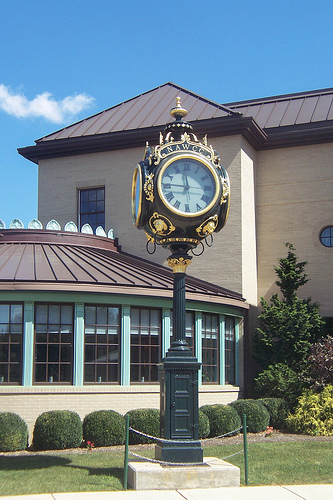<image>
Is there a plant behind the pole? Yes. From this viewpoint, the plant is positioned behind the pole, with the pole partially or fully occluding the plant. Where is the house in relation to the clock? Is it behind the clock? Yes. From this viewpoint, the house is positioned behind the clock, with the clock partially or fully occluding the house. 